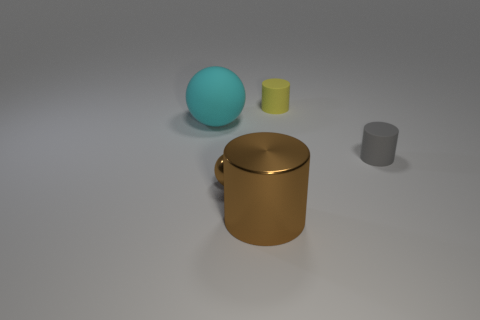How many big matte objects are there?
Make the answer very short. 1. There is a tiny matte thing on the left side of the object that is on the right side of the yellow object; what shape is it?
Give a very brief answer. Cylinder. There is a big brown object; how many big cyan rubber spheres are behind it?
Your answer should be compact. 1. Does the small gray cylinder have the same material as the brown thing that is on the left side of the large cylinder?
Provide a short and direct response. No. Is there a gray rubber cylinder that has the same size as the brown cylinder?
Provide a short and direct response. No. Is the number of rubber spheres behind the large cyan matte thing the same as the number of gray metallic cubes?
Give a very brief answer. Yes. How big is the gray object?
Make the answer very short. Small. What number of tiny brown shiny balls are on the right side of the tiny rubber thing that is in front of the small yellow matte cylinder?
Offer a very short reply. 0. There is a rubber object that is behind the gray cylinder and to the right of the big metallic thing; what shape is it?
Provide a succinct answer. Cylinder. How many other spheres are the same color as the small ball?
Keep it short and to the point. 0. 